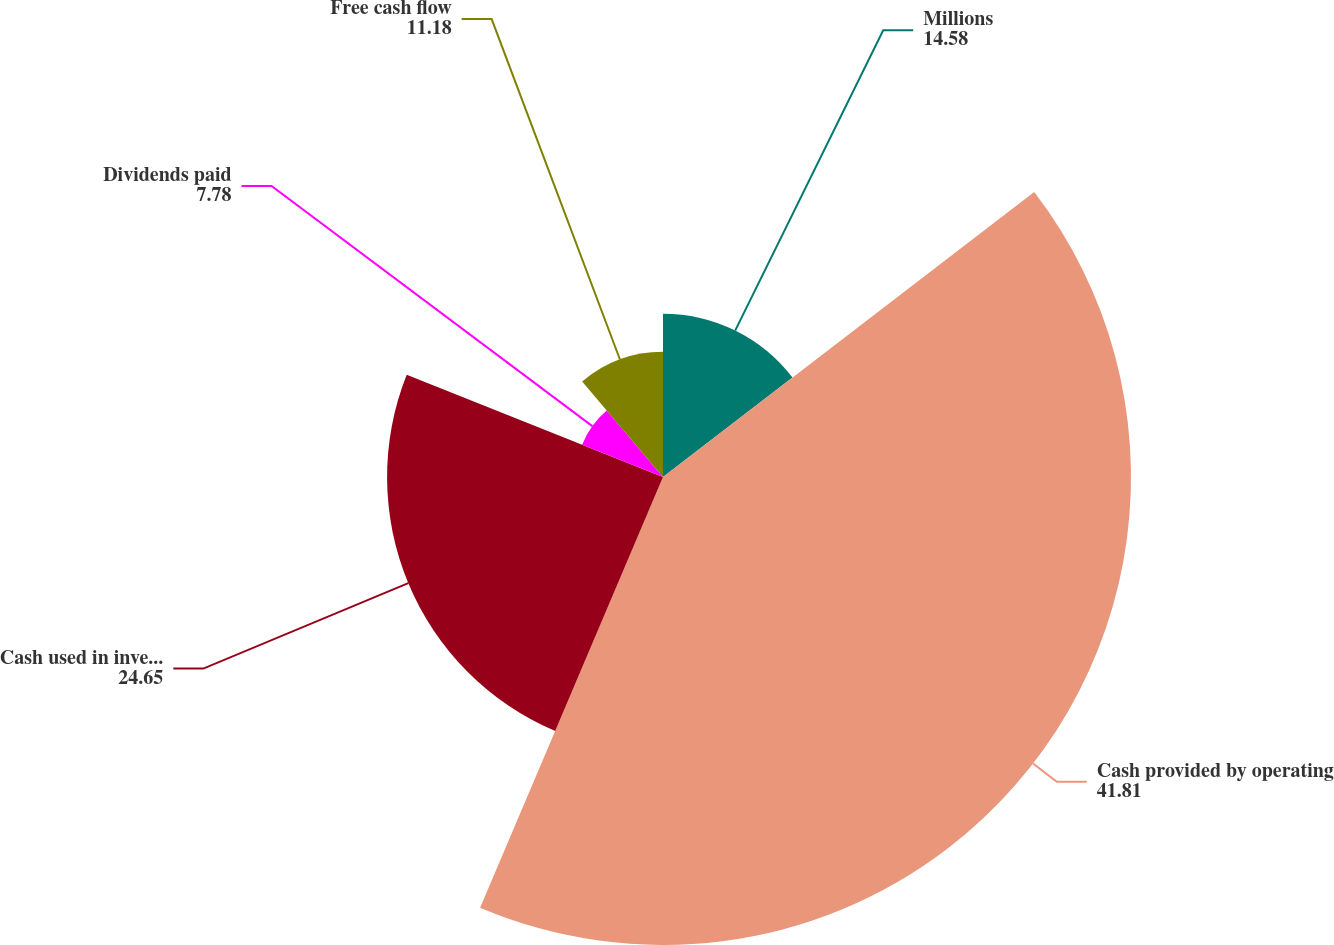Convert chart to OTSL. <chart><loc_0><loc_0><loc_500><loc_500><pie_chart><fcel>Millions<fcel>Cash provided by operating<fcel>Cash used in investing<fcel>Dividends paid<fcel>Free cash flow<nl><fcel>14.58%<fcel>41.81%<fcel>24.65%<fcel>7.78%<fcel>11.18%<nl></chart> 